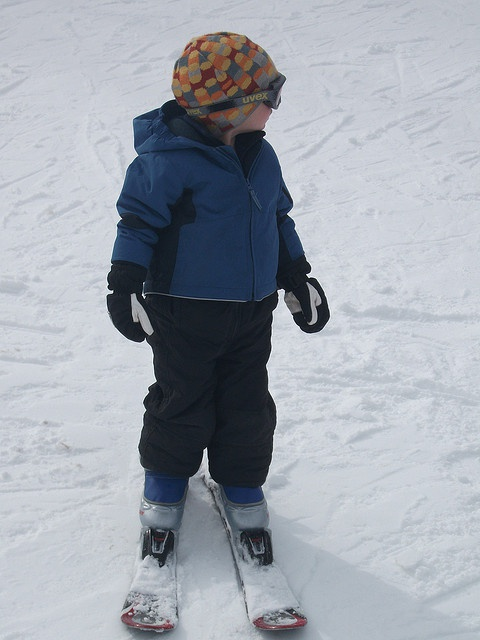Describe the objects in this image and their specific colors. I can see people in darkgray, black, navy, gray, and darkblue tones and skis in darkgray, gray, and lightgray tones in this image. 